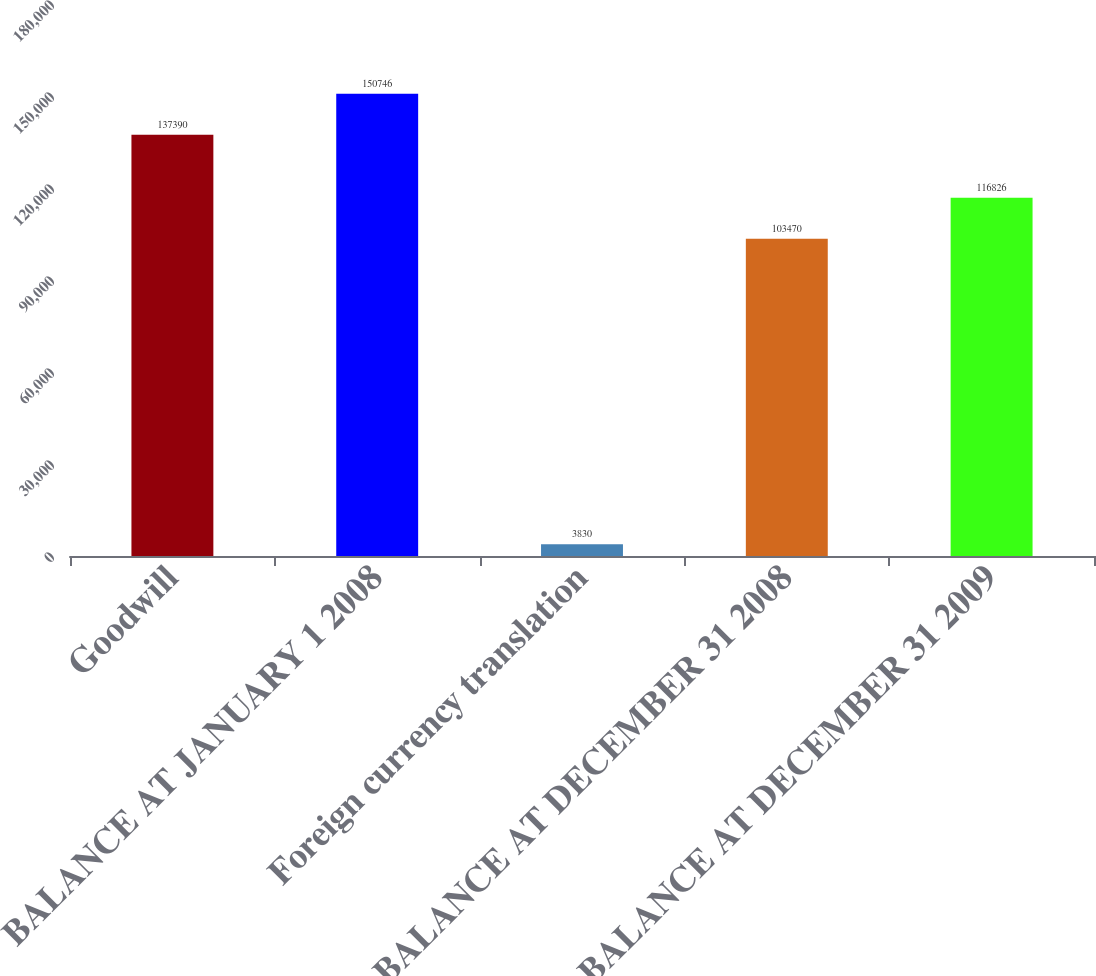Convert chart. <chart><loc_0><loc_0><loc_500><loc_500><bar_chart><fcel>Goodwill<fcel>BALANCE AT JANUARY 1 2008<fcel>Foreign currency translation<fcel>BALANCE AT DECEMBER 31 2008<fcel>BALANCE AT DECEMBER 31 2009<nl><fcel>137390<fcel>150746<fcel>3830<fcel>103470<fcel>116826<nl></chart> 